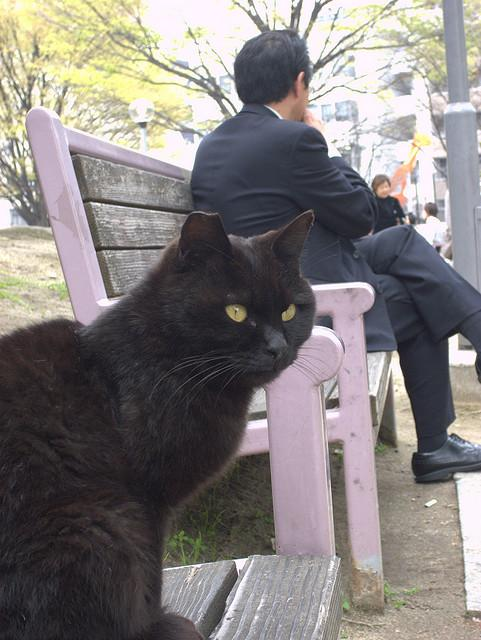What animal is on the bench? cat 